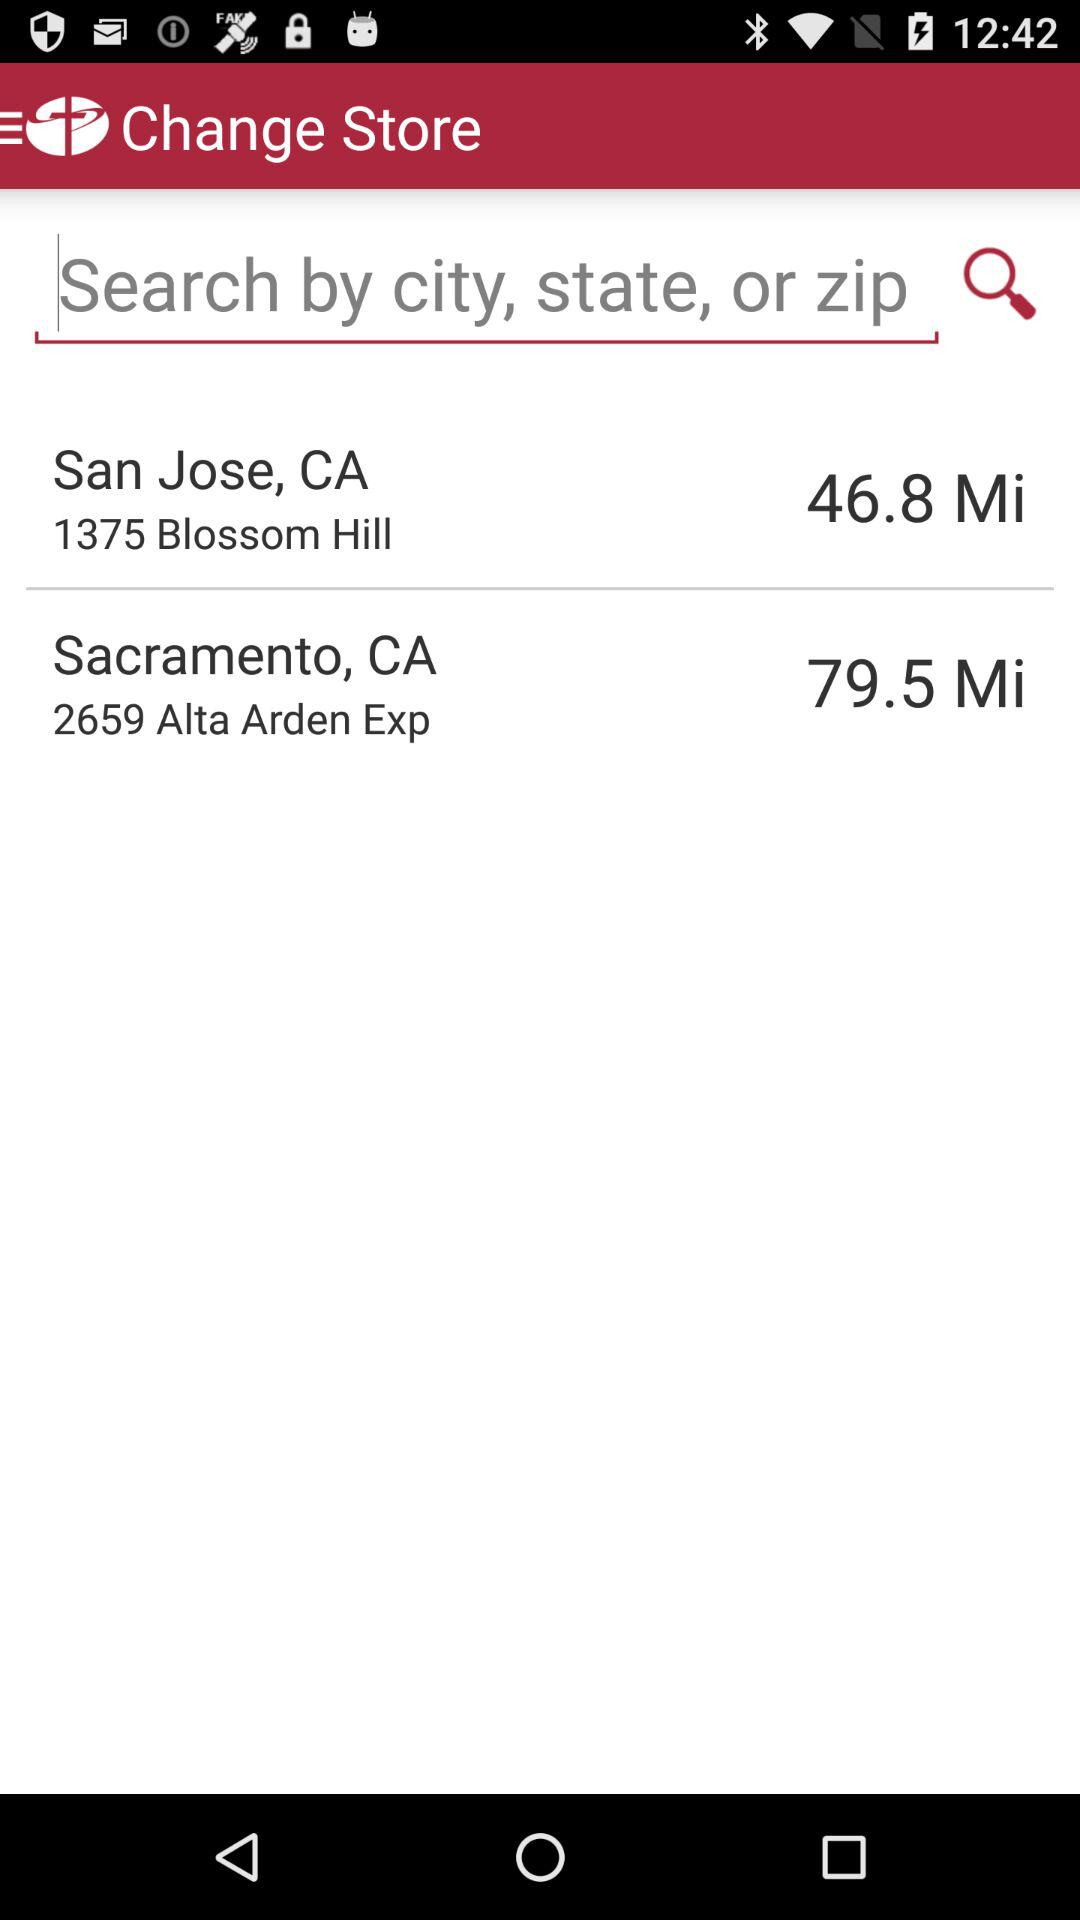What is the distance between my location and Sacramento, CA? The distance between my location and Sacramento, CA, is 79.5 miles. 